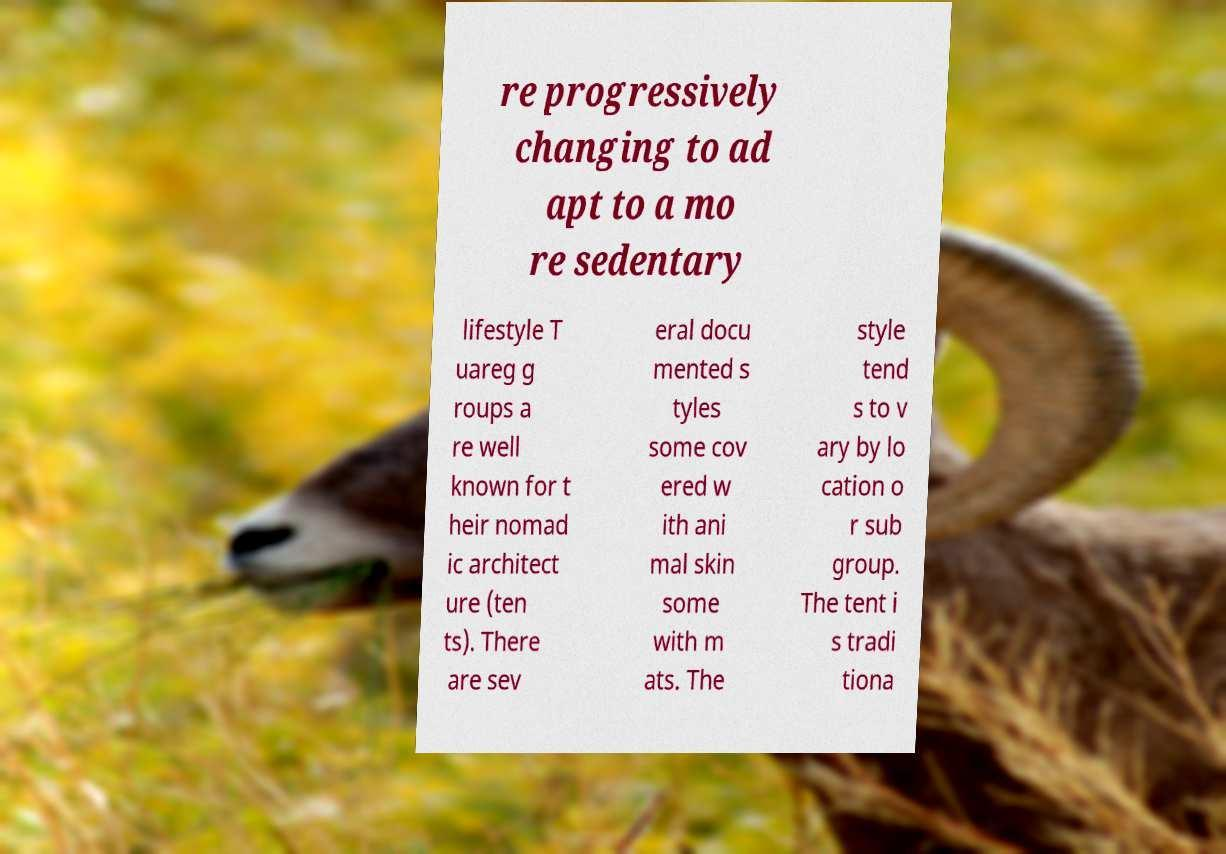For documentation purposes, I need the text within this image transcribed. Could you provide that? re progressively changing to ad apt to a mo re sedentary lifestyle T uareg g roups a re well known for t heir nomad ic architect ure (ten ts). There are sev eral docu mented s tyles some cov ered w ith ani mal skin some with m ats. The style tend s to v ary by lo cation o r sub group. The tent i s tradi tiona 